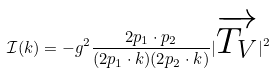Convert formula to latex. <formula><loc_0><loc_0><loc_500><loc_500>\mathcal { I } ( k ) = - g ^ { 2 } \frac { 2 p _ { 1 } \cdot p _ { 2 } } { ( 2 p _ { 1 } \cdot k ) ( 2 p _ { 2 } \cdot k ) } | \overrightarrow { T _ { V } } | ^ { 2 }</formula> 